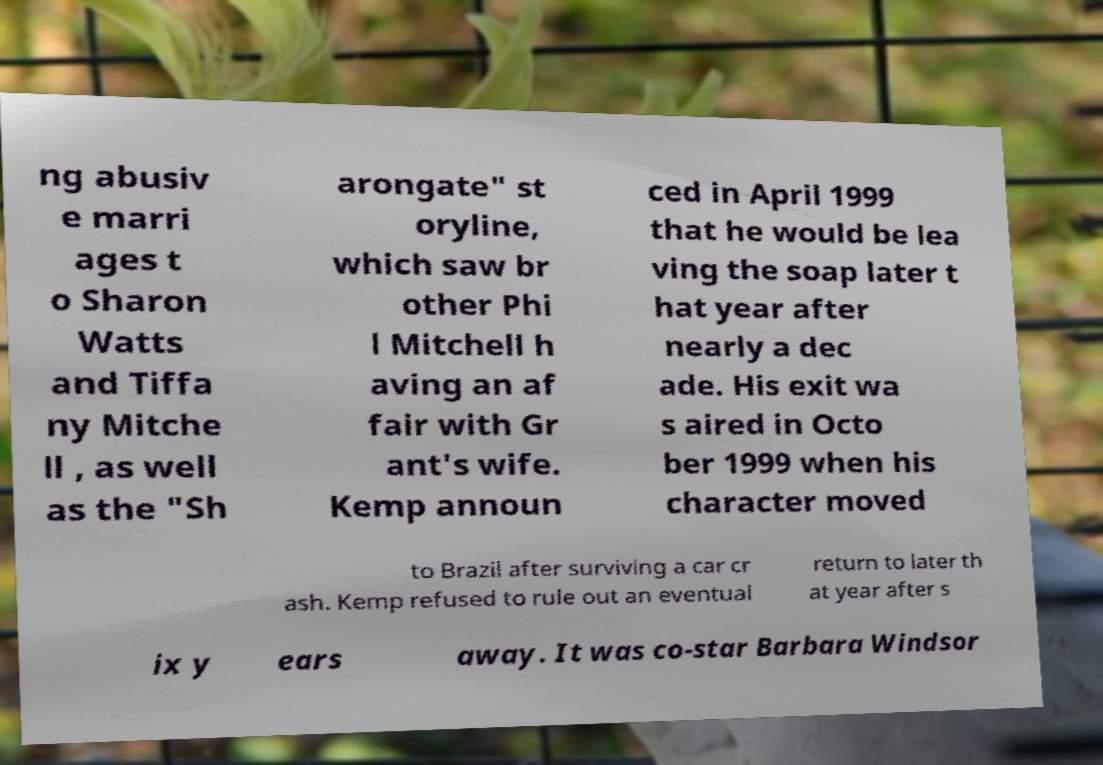There's text embedded in this image that I need extracted. Can you transcribe it verbatim? ng abusiv e marri ages t o Sharon Watts and Tiffa ny Mitche ll , as well as the "Sh arongate" st oryline, which saw br other Phi l Mitchell h aving an af fair with Gr ant's wife. Kemp announ ced in April 1999 that he would be lea ving the soap later t hat year after nearly a dec ade. His exit wa s aired in Octo ber 1999 when his character moved to Brazil after surviving a car cr ash. Kemp refused to rule out an eventual return to later th at year after s ix y ears away. It was co-star Barbara Windsor 